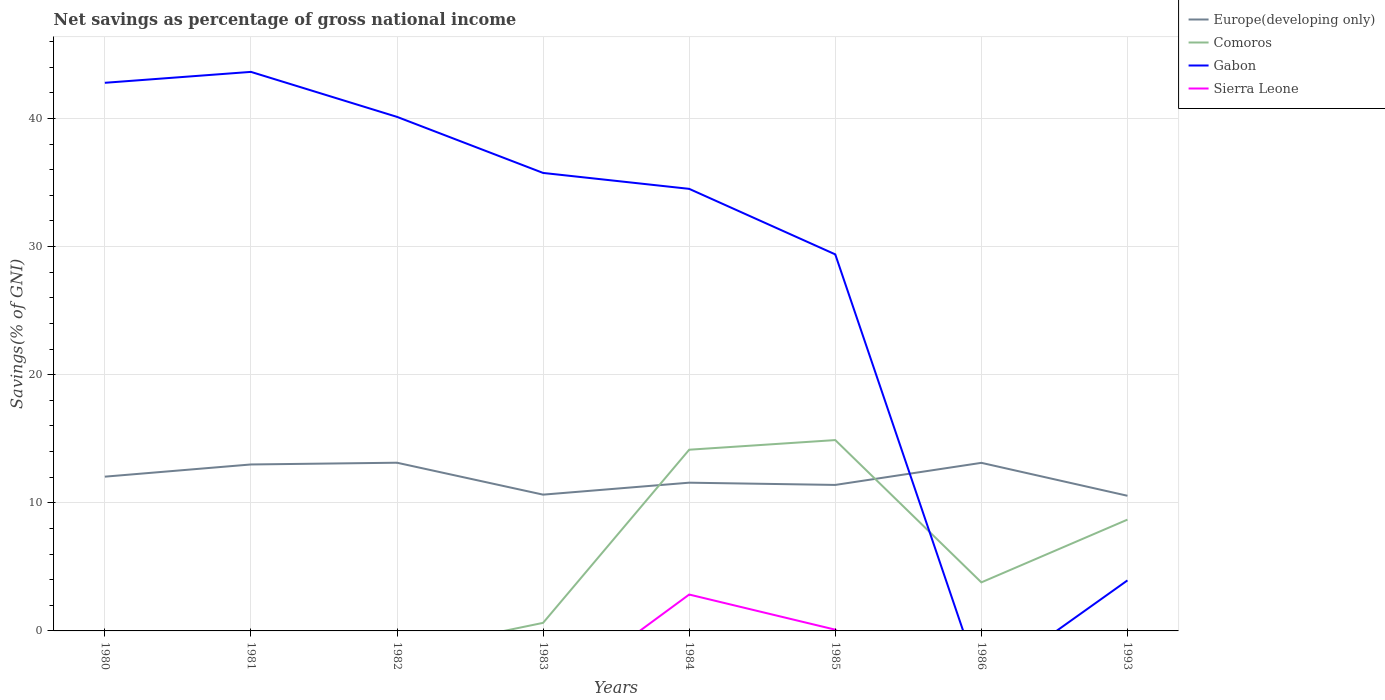Does the line corresponding to Gabon intersect with the line corresponding to Comoros?
Your answer should be very brief. Yes. Across all years, what is the maximum total savings in Sierra Leone?
Keep it short and to the point. 0. What is the total total savings in Europe(developing only) in the graph?
Provide a short and direct response. 2.58. What is the difference between the highest and the second highest total savings in Comoros?
Offer a very short reply. 14.9. What is the difference between the highest and the lowest total savings in Gabon?
Make the answer very short. 6. How many lines are there?
Ensure brevity in your answer.  4. How many years are there in the graph?
Your answer should be very brief. 8. Are the values on the major ticks of Y-axis written in scientific E-notation?
Make the answer very short. No. Does the graph contain any zero values?
Your response must be concise. Yes. What is the title of the graph?
Keep it short and to the point. Net savings as percentage of gross national income. Does "Nicaragua" appear as one of the legend labels in the graph?
Your answer should be very brief. No. What is the label or title of the Y-axis?
Your answer should be very brief. Savings(% of GNI). What is the Savings(% of GNI) of Europe(developing only) in 1980?
Your answer should be compact. 12.04. What is the Savings(% of GNI) in Gabon in 1980?
Keep it short and to the point. 42.78. What is the Savings(% of GNI) of Sierra Leone in 1980?
Your answer should be very brief. 0. What is the Savings(% of GNI) of Europe(developing only) in 1981?
Provide a short and direct response. 12.99. What is the Savings(% of GNI) of Comoros in 1981?
Give a very brief answer. 0. What is the Savings(% of GNI) in Gabon in 1981?
Keep it short and to the point. 43.64. What is the Savings(% of GNI) of Europe(developing only) in 1982?
Offer a terse response. 13.13. What is the Savings(% of GNI) of Comoros in 1982?
Offer a terse response. 0. What is the Savings(% of GNI) of Gabon in 1982?
Provide a succinct answer. 40.12. What is the Savings(% of GNI) of Europe(developing only) in 1983?
Make the answer very short. 10.64. What is the Savings(% of GNI) of Comoros in 1983?
Provide a succinct answer. 0.63. What is the Savings(% of GNI) in Gabon in 1983?
Provide a short and direct response. 35.75. What is the Savings(% of GNI) of Europe(developing only) in 1984?
Provide a succinct answer. 11.57. What is the Savings(% of GNI) in Comoros in 1984?
Keep it short and to the point. 14.14. What is the Savings(% of GNI) in Gabon in 1984?
Your answer should be compact. 34.51. What is the Savings(% of GNI) of Sierra Leone in 1984?
Keep it short and to the point. 2.84. What is the Savings(% of GNI) of Europe(developing only) in 1985?
Keep it short and to the point. 11.4. What is the Savings(% of GNI) of Comoros in 1985?
Offer a terse response. 14.9. What is the Savings(% of GNI) of Gabon in 1985?
Your answer should be very brief. 29.39. What is the Savings(% of GNI) in Sierra Leone in 1985?
Offer a very short reply. 0.1. What is the Savings(% of GNI) in Europe(developing only) in 1986?
Provide a short and direct response. 13.12. What is the Savings(% of GNI) in Comoros in 1986?
Provide a short and direct response. 3.79. What is the Savings(% of GNI) in Europe(developing only) in 1993?
Give a very brief answer. 10.55. What is the Savings(% of GNI) in Comoros in 1993?
Give a very brief answer. 8.69. What is the Savings(% of GNI) of Gabon in 1993?
Ensure brevity in your answer.  3.94. What is the Savings(% of GNI) of Sierra Leone in 1993?
Make the answer very short. 0. Across all years, what is the maximum Savings(% of GNI) of Europe(developing only)?
Offer a terse response. 13.13. Across all years, what is the maximum Savings(% of GNI) of Comoros?
Your response must be concise. 14.9. Across all years, what is the maximum Savings(% of GNI) in Gabon?
Provide a short and direct response. 43.64. Across all years, what is the maximum Savings(% of GNI) in Sierra Leone?
Provide a short and direct response. 2.84. Across all years, what is the minimum Savings(% of GNI) in Europe(developing only)?
Your answer should be very brief. 10.55. Across all years, what is the minimum Savings(% of GNI) of Comoros?
Ensure brevity in your answer.  0. Across all years, what is the minimum Savings(% of GNI) of Sierra Leone?
Your answer should be compact. 0. What is the total Savings(% of GNI) of Europe(developing only) in the graph?
Provide a short and direct response. 95.44. What is the total Savings(% of GNI) in Comoros in the graph?
Offer a very short reply. 42.15. What is the total Savings(% of GNI) in Gabon in the graph?
Offer a terse response. 230.13. What is the total Savings(% of GNI) of Sierra Leone in the graph?
Provide a succinct answer. 2.94. What is the difference between the Savings(% of GNI) of Europe(developing only) in 1980 and that in 1981?
Your answer should be very brief. -0.95. What is the difference between the Savings(% of GNI) of Gabon in 1980 and that in 1981?
Your answer should be compact. -0.85. What is the difference between the Savings(% of GNI) in Europe(developing only) in 1980 and that in 1982?
Offer a very short reply. -1.09. What is the difference between the Savings(% of GNI) in Gabon in 1980 and that in 1982?
Offer a terse response. 2.66. What is the difference between the Savings(% of GNI) in Europe(developing only) in 1980 and that in 1983?
Your answer should be compact. 1.4. What is the difference between the Savings(% of GNI) in Gabon in 1980 and that in 1983?
Offer a terse response. 7.04. What is the difference between the Savings(% of GNI) of Europe(developing only) in 1980 and that in 1984?
Provide a short and direct response. 0.47. What is the difference between the Savings(% of GNI) in Gabon in 1980 and that in 1984?
Ensure brevity in your answer.  8.28. What is the difference between the Savings(% of GNI) of Europe(developing only) in 1980 and that in 1985?
Ensure brevity in your answer.  0.64. What is the difference between the Savings(% of GNI) of Gabon in 1980 and that in 1985?
Give a very brief answer. 13.39. What is the difference between the Savings(% of GNI) of Europe(developing only) in 1980 and that in 1986?
Provide a succinct answer. -1.08. What is the difference between the Savings(% of GNI) in Europe(developing only) in 1980 and that in 1993?
Offer a terse response. 1.49. What is the difference between the Savings(% of GNI) of Gabon in 1980 and that in 1993?
Provide a succinct answer. 38.84. What is the difference between the Savings(% of GNI) in Europe(developing only) in 1981 and that in 1982?
Give a very brief answer. -0.14. What is the difference between the Savings(% of GNI) in Gabon in 1981 and that in 1982?
Offer a terse response. 3.51. What is the difference between the Savings(% of GNI) in Europe(developing only) in 1981 and that in 1983?
Make the answer very short. 2.36. What is the difference between the Savings(% of GNI) in Gabon in 1981 and that in 1983?
Make the answer very short. 7.89. What is the difference between the Savings(% of GNI) of Europe(developing only) in 1981 and that in 1984?
Keep it short and to the point. 1.42. What is the difference between the Savings(% of GNI) in Gabon in 1981 and that in 1984?
Provide a succinct answer. 9.13. What is the difference between the Savings(% of GNI) in Europe(developing only) in 1981 and that in 1985?
Ensure brevity in your answer.  1.6. What is the difference between the Savings(% of GNI) of Gabon in 1981 and that in 1985?
Keep it short and to the point. 14.24. What is the difference between the Savings(% of GNI) of Europe(developing only) in 1981 and that in 1986?
Your answer should be compact. -0.13. What is the difference between the Savings(% of GNI) in Europe(developing only) in 1981 and that in 1993?
Ensure brevity in your answer.  2.44. What is the difference between the Savings(% of GNI) in Gabon in 1981 and that in 1993?
Provide a short and direct response. 39.69. What is the difference between the Savings(% of GNI) of Europe(developing only) in 1982 and that in 1983?
Give a very brief answer. 2.49. What is the difference between the Savings(% of GNI) in Gabon in 1982 and that in 1983?
Keep it short and to the point. 4.38. What is the difference between the Savings(% of GNI) of Europe(developing only) in 1982 and that in 1984?
Provide a short and direct response. 1.56. What is the difference between the Savings(% of GNI) in Gabon in 1982 and that in 1984?
Your response must be concise. 5.62. What is the difference between the Savings(% of GNI) in Europe(developing only) in 1982 and that in 1985?
Provide a short and direct response. 1.73. What is the difference between the Savings(% of GNI) of Gabon in 1982 and that in 1985?
Make the answer very short. 10.73. What is the difference between the Savings(% of GNI) of Europe(developing only) in 1982 and that in 1986?
Provide a short and direct response. 0.01. What is the difference between the Savings(% of GNI) of Europe(developing only) in 1982 and that in 1993?
Keep it short and to the point. 2.58. What is the difference between the Savings(% of GNI) in Gabon in 1982 and that in 1993?
Your response must be concise. 36.18. What is the difference between the Savings(% of GNI) of Europe(developing only) in 1983 and that in 1984?
Offer a terse response. -0.93. What is the difference between the Savings(% of GNI) in Comoros in 1983 and that in 1984?
Ensure brevity in your answer.  -13.51. What is the difference between the Savings(% of GNI) of Gabon in 1983 and that in 1984?
Offer a terse response. 1.24. What is the difference between the Savings(% of GNI) in Europe(developing only) in 1983 and that in 1985?
Provide a short and direct response. -0.76. What is the difference between the Savings(% of GNI) in Comoros in 1983 and that in 1985?
Offer a terse response. -14.27. What is the difference between the Savings(% of GNI) of Gabon in 1983 and that in 1985?
Give a very brief answer. 6.36. What is the difference between the Savings(% of GNI) of Europe(developing only) in 1983 and that in 1986?
Ensure brevity in your answer.  -2.48. What is the difference between the Savings(% of GNI) of Comoros in 1983 and that in 1986?
Offer a terse response. -3.16. What is the difference between the Savings(% of GNI) of Europe(developing only) in 1983 and that in 1993?
Provide a short and direct response. 0.09. What is the difference between the Savings(% of GNI) in Comoros in 1983 and that in 1993?
Offer a terse response. -8.06. What is the difference between the Savings(% of GNI) in Gabon in 1983 and that in 1993?
Make the answer very short. 31.8. What is the difference between the Savings(% of GNI) in Europe(developing only) in 1984 and that in 1985?
Your answer should be very brief. 0.17. What is the difference between the Savings(% of GNI) in Comoros in 1984 and that in 1985?
Your answer should be compact. -0.75. What is the difference between the Savings(% of GNI) in Gabon in 1984 and that in 1985?
Your response must be concise. 5.12. What is the difference between the Savings(% of GNI) in Sierra Leone in 1984 and that in 1985?
Provide a succinct answer. 2.74. What is the difference between the Savings(% of GNI) of Europe(developing only) in 1984 and that in 1986?
Offer a terse response. -1.55. What is the difference between the Savings(% of GNI) in Comoros in 1984 and that in 1986?
Your response must be concise. 10.35. What is the difference between the Savings(% of GNI) in Europe(developing only) in 1984 and that in 1993?
Your answer should be very brief. 1.02. What is the difference between the Savings(% of GNI) of Comoros in 1984 and that in 1993?
Keep it short and to the point. 5.46. What is the difference between the Savings(% of GNI) of Gabon in 1984 and that in 1993?
Your answer should be very brief. 30.56. What is the difference between the Savings(% of GNI) in Europe(developing only) in 1985 and that in 1986?
Provide a short and direct response. -1.72. What is the difference between the Savings(% of GNI) of Comoros in 1985 and that in 1986?
Make the answer very short. 11.11. What is the difference between the Savings(% of GNI) in Europe(developing only) in 1985 and that in 1993?
Your answer should be very brief. 0.85. What is the difference between the Savings(% of GNI) of Comoros in 1985 and that in 1993?
Ensure brevity in your answer.  6.21. What is the difference between the Savings(% of GNI) in Gabon in 1985 and that in 1993?
Keep it short and to the point. 25.45. What is the difference between the Savings(% of GNI) in Europe(developing only) in 1986 and that in 1993?
Provide a succinct answer. 2.57. What is the difference between the Savings(% of GNI) of Comoros in 1986 and that in 1993?
Give a very brief answer. -4.9. What is the difference between the Savings(% of GNI) of Europe(developing only) in 1980 and the Savings(% of GNI) of Gabon in 1981?
Provide a short and direct response. -31.6. What is the difference between the Savings(% of GNI) of Europe(developing only) in 1980 and the Savings(% of GNI) of Gabon in 1982?
Your answer should be very brief. -28.08. What is the difference between the Savings(% of GNI) in Europe(developing only) in 1980 and the Savings(% of GNI) in Comoros in 1983?
Give a very brief answer. 11.41. What is the difference between the Savings(% of GNI) in Europe(developing only) in 1980 and the Savings(% of GNI) in Gabon in 1983?
Ensure brevity in your answer.  -23.71. What is the difference between the Savings(% of GNI) in Europe(developing only) in 1980 and the Savings(% of GNI) in Comoros in 1984?
Your response must be concise. -2.1. What is the difference between the Savings(% of GNI) of Europe(developing only) in 1980 and the Savings(% of GNI) of Gabon in 1984?
Provide a short and direct response. -22.47. What is the difference between the Savings(% of GNI) in Europe(developing only) in 1980 and the Savings(% of GNI) in Sierra Leone in 1984?
Your answer should be compact. 9.2. What is the difference between the Savings(% of GNI) in Gabon in 1980 and the Savings(% of GNI) in Sierra Leone in 1984?
Provide a succinct answer. 39.94. What is the difference between the Savings(% of GNI) of Europe(developing only) in 1980 and the Savings(% of GNI) of Comoros in 1985?
Offer a terse response. -2.86. What is the difference between the Savings(% of GNI) of Europe(developing only) in 1980 and the Savings(% of GNI) of Gabon in 1985?
Provide a succinct answer. -17.35. What is the difference between the Savings(% of GNI) of Europe(developing only) in 1980 and the Savings(% of GNI) of Sierra Leone in 1985?
Offer a very short reply. 11.94. What is the difference between the Savings(% of GNI) in Gabon in 1980 and the Savings(% of GNI) in Sierra Leone in 1985?
Ensure brevity in your answer.  42.69. What is the difference between the Savings(% of GNI) of Europe(developing only) in 1980 and the Savings(% of GNI) of Comoros in 1986?
Your response must be concise. 8.25. What is the difference between the Savings(% of GNI) of Europe(developing only) in 1980 and the Savings(% of GNI) of Comoros in 1993?
Provide a succinct answer. 3.35. What is the difference between the Savings(% of GNI) in Europe(developing only) in 1980 and the Savings(% of GNI) in Gabon in 1993?
Ensure brevity in your answer.  8.1. What is the difference between the Savings(% of GNI) in Europe(developing only) in 1981 and the Savings(% of GNI) in Gabon in 1982?
Your answer should be very brief. -27.13. What is the difference between the Savings(% of GNI) of Europe(developing only) in 1981 and the Savings(% of GNI) of Comoros in 1983?
Give a very brief answer. 12.36. What is the difference between the Savings(% of GNI) of Europe(developing only) in 1981 and the Savings(% of GNI) of Gabon in 1983?
Provide a succinct answer. -22.76. What is the difference between the Savings(% of GNI) in Europe(developing only) in 1981 and the Savings(% of GNI) in Comoros in 1984?
Your answer should be very brief. -1.15. What is the difference between the Savings(% of GNI) of Europe(developing only) in 1981 and the Savings(% of GNI) of Gabon in 1984?
Keep it short and to the point. -21.51. What is the difference between the Savings(% of GNI) of Europe(developing only) in 1981 and the Savings(% of GNI) of Sierra Leone in 1984?
Offer a terse response. 10.15. What is the difference between the Savings(% of GNI) in Gabon in 1981 and the Savings(% of GNI) in Sierra Leone in 1984?
Ensure brevity in your answer.  40.8. What is the difference between the Savings(% of GNI) of Europe(developing only) in 1981 and the Savings(% of GNI) of Comoros in 1985?
Offer a very short reply. -1.9. What is the difference between the Savings(% of GNI) of Europe(developing only) in 1981 and the Savings(% of GNI) of Gabon in 1985?
Your response must be concise. -16.4. What is the difference between the Savings(% of GNI) in Europe(developing only) in 1981 and the Savings(% of GNI) in Sierra Leone in 1985?
Keep it short and to the point. 12.9. What is the difference between the Savings(% of GNI) of Gabon in 1981 and the Savings(% of GNI) of Sierra Leone in 1985?
Keep it short and to the point. 43.54. What is the difference between the Savings(% of GNI) in Europe(developing only) in 1981 and the Savings(% of GNI) in Comoros in 1986?
Offer a very short reply. 9.2. What is the difference between the Savings(% of GNI) of Europe(developing only) in 1981 and the Savings(% of GNI) of Comoros in 1993?
Your answer should be very brief. 4.31. What is the difference between the Savings(% of GNI) of Europe(developing only) in 1981 and the Savings(% of GNI) of Gabon in 1993?
Your response must be concise. 9.05. What is the difference between the Savings(% of GNI) of Europe(developing only) in 1982 and the Savings(% of GNI) of Comoros in 1983?
Your answer should be compact. 12.5. What is the difference between the Savings(% of GNI) of Europe(developing only) in 1982 and the Savings(% of GNI) of Gabon in 1983?
Your answer should be very brief. -22.62. What is the difference between the Savings(% of GNI) of Europe(developing only) in 1982 and the Savings(% of GNI) of Comoros in 1984?
Ensure brevity in your answer.  -1.01. What is the difference between the Savings(% of GNI) of Europe(developing only) in 1982 and the Savings(% of GNI) of Gabon in 1984?
Keep it short and to the point. -21.38. What is the difference between the Savings(% of GNI) in Europe(developing only) in 1982 and the Savings(% of GNI) in Sierra Leone in 1984?
Provide a short and direct response. 10.29. What is the difference between the Savings(% of GNI) of Gabon in 1982 and the Savings(% of GNI) of Sierra Leone in 1984?
Make the answer very short. 37.28. What is the difference between the Savings(% of GNI) in Europe(developing only) in 1982 and the Savings(% of GNI) in Comoros in 1985?
Offer a terse response. -1.77. What is the difference between the Savings(% of GNI) of Europe(developing only) in 1982 and the Savings(% of GNI) of Gabon in 1985?
Provide a succinct answer. -16.26. What is the difference between the Savings(% of GNI) in Europe(developing only) in 1982 and the Savings(% of GNI) in Sierra Leone in 1985?
Your answer should be compact. 13.03. What is the difference between the Savings(% of GNI) of Gabon in 1982 and the Savings(% of GNI) of Sierra Leone in 1985?
Your answer should be compact. 40.03. What is the difference between the Savings(% of GNI) in Europe(developing only) in 1982 and the Savings(% of GNI) in Comoros in 1986?
Make the answer very short. 9.34. What is the difference between the Savings(% of GNI) of Europe(developing only) in 1982 and the Savings(% of GNI) of Comoros in 1993?
Make the answer very short. 4.44. What is the difference between the Savings(% of GNI) of Europe(developing only) in 1982 and the Savings(% of GNI) of Gabon in 1993?
Provide a short and direct response. 9.18. What is the difference between the Savings(% of GNI) in Europe(developing only) in 1983 and the Savings(% of GNI) in Comoros in 1984?
Offer a terse response. -3.51. What is the difference between the Savings(% of GNI) in Europe(developing only) in 1983 and the Savings(% of GNI) in Gabon in 1984?
Keep it short and to the point. -23.87. What is the difference between the Savings(% of GNI) of Europe(developing only) in 1983 and the Savings(% of GNI) of Sierra Leone in 1984?
Your answer should be compact. 7.8. What is the difference between the Savings(% of GNI) in Comoros in 1983 and the Savings(% of GNI) in Gabon in 1984?
Give a very brief answer. -33.88. What is the difference between the Savings(% of GNI) of Comoros in 1983 and the Savings(% of GNI) of Sierra Leone in 1984?
Your answer should be compact. -2.21. What is the difference between the Savings(% of GNI) in Gabon in 1983 and the Savings(% of GNI) in Sierra Leone in 1984?
Provide a short and direct response. 32.91. What is the difference between the Savings(% of GNI) in Europe(developing only) in 1983 and the Savings(% of GNI) in Comoros in 1985?
Your answer should be very brief. -4.26. What is the difference between the Savings(% of GNI) of Europe(developing only) in 1983 and the Savings(% of GNI) of Gabon in 1985?
Ensure brevity in your answer.  -18.75. What is the difference between the Savings(% of GNI) in Europe(developing only) in 1983 and the Savings(% of GNI) in Sierra Leone in 1985?
Provide a short and direct response. 10.54. What is the difference between the Savings(% of GNI) of Comoros in 1983 and the Savings(% of GNI) of Gabon in 1985?
Your answer should be compact. -28.76. What is the difference between the Savings(% of GNI) of Comoros in 1983 and the Savings(% of GNI) of Sierra Leone in 1985?
Offer a terse response. 0.53. What is the difference between the Savings(% of GNI) of Gabon in 1983 and the Savings(% of GNI) of Sierra Leone in 1985?
Offer a terse response. 35.65. What is the difference between the Savings(% of GNI) of Europe(developing only) in 1983 and the Savings(% of GNI) of Comoros in 1986?
Provide a succinct answer. 6.85. What is the difference between the Savings(% of GNI) of Europe(developing only) in 1983 and the Savings(% of GNI) of Comoros in 1993?
Provide a succinct answer. 1.95. What is the difference between the Savings(% of GNI) in Europe(developing only) in 1983 and the Savings(% of GNI) in Gabon in 1993?
Your response must be concise. 6.69. What is the difference between the Savings(% of GNI) of Comoros in 1983 and the Savings(% of GNI) of Gabon in 1993?
Offer a terse response. -3.31. What is the difference between the Savings(% of GNI) in Europe(developing only) in 1984 and the Savings(% of GNI) in Comoros in 1985?
Give a very brief answer. -3.33. What is the difference between the Savings(% of GNI) in Europe(developing only) in 1984 and the Savings(% of GNI) in Gabon in 1985?
Make the answer very short. -17.82. What is the difference between the Savings(% of GNI) of Europe(developing only) in 1984 and the Savings(% of GNI) of Sierra Leone in 1985?
Your response must be concise. 11.47. What is the difference between the Savings(% of GNI) of Comoros in 1984 and the Savings(% of GNI) of Gabon in 1985?
Offer a very short reply. -15.25. What is the difference between the Savings(% of GNI) of Comoros in 1984 and the Savings(% of GNI) of Sierra Leone in 1985?
Your answer should be compact. 14.05. What is the difference between the Savings(% of GNI) in Gabon in 1984 and the Savings(% of GNI) in Sierra Leone in 1985?
Offer a terse response. 34.41. What is the difference between the Savings(% of GNI) of Europe(developing only) in 1984 and the Savings(% of GNI) of Comoros in 1986?
Make the answer very short. 7.78. What is the difference between the Savings(% of GNI) in Europe(developing only) in 1984 and the Savings(% of GNI) in Comoros in 1993?
Make the answer very short. 2.88. What is the difference between the Savings(% of GNI) in Europe(developing only) in 1984 and the Savings(% of GNI) in Gabon in 1993?
Your answer should be compact. 7.63. What is the difference between the Savings(% of GNI) of Comoros in 1984 and the Savings(% of GNI) of Gabon in 1993?
Ensure brevity in your answer.  10.2. What is the difference between the Savings(% of GNI) in Europe(developing only) in 1985 and the Savings(% of GNI) in Comoros in 1986?
Give a very brief answer. 7.61. What is the difference between the Savings(% of GNI) in Europe(developing only) in 1985 and the Savings(% of GNI) in Comoros in 1993?
Your answer should be very brief. 2.71. What is the difference between the Savings(% of GNI) in Europe(developing only) in 1985 and the Savings(% of GNI) in Gabon in 1993?
Ensure brevity in your answer.  7.45. What is the difference between the Savings(% of GNI) in Comoros in 1985 and the Savings(% of GNI) in Gabon in 1993?
Make the answer very short. 10.95. What is the difference between the Savings(% of GNI) of Europe(developing only) in 1986 and the Savings(% of GNI) of Comoros in 1993?
Your response must be concise. 4.43. What is the difference between the Savings(% of GNI) of Europe(developing only) in 1986 and the Savings(% of GNI) of Gabon in 1993?
Make the answer very short. 9.17. What is the difference between the Savings(% of GNI) of Comoros in 1986 and the Savings(% of GNI) of Gabon in 1993?
Provide a succinct answer. -0.15. What is the average Savings(% of GNI) of Europe(developing only) per year?
Provide a succinct answer. 11.93. What is the average Savings(% of GNI) in Comoros per year?
Your answer should be very brief. 5.27. What is the average Savings(% of GNI) in Gabon per year?
Your answer should be compact. 28.77. What is the average Savings(% of GNI) in Sierra Leone per year?
Keep it short and to the point. 0.37. In the year 1980, what is the difference between the Savings(% of GNI) in Europe(developing only) and Savings(% of GNI) in Gabon?
Keep it short and to the point. -30.74. In the year 1981, what is the difference between the Savings(% of GNI) in Europe(developing only) and Savings(% of GNI) in Gabon?
Your answer should be very brief. -30.64. In the year 1982, what is the difference between the Savings(% of GNI) of Europe(developing only) and Savings(% of GNI) of Gabon?
Offer a very short reply. -27. In the year 1983, what is the difference between the Savings(% of GNI) of Europe(developing only) and Savings(% of GNI) of Comoros?
Your answer should be very brief. 10.01. In the year 1983, what is the difference between the Savings(% of GNI) in Europe(developing only) and Savings(% of GNI) in Gabon?
Provide a succinct answer. -25.11. In the year 1983, what is the difference between the Savings(% of GNI) in Comoros and Savings(% of GNI) in Gabon?
Ensure brevity in your answer.  -35.12. In the year 1984, what is the difference between the Savings(% of GNI) of Europe(developing only) and Savings(% of GNI) of Comoros?
Provide a succinct answer. -2.57. In the year 1984, what is the difference between the Savings(% of GNI) in Europe(developing only) and Savings(% of GNI) in Gabon?
Provide a succinct answer. -22.94. In the year 1984, what is the difference between the Savings(% of GNI) in Europe(developing only) and Savings(% of GNI) in Sierra Leone?
Your answer should be compact. 8.73. In the year 1984, what is the difference between the Savings(% of GNI) in Comoros and Savings(% of GNI) in Gabon?
Provide a succinct answer. -20.36. In the year 1984, what is the difference between the Savings(% of GNI) of Comoros and Savings(% of GNI) of Sierra Leone?
Your answer should be compact. 11.3. In the year 1984, what is the difference between the Savings(% of GNI) of Gabon and Savings(% of GNI) of Sierra Leone?
Your answer should be compact. 31.67. In the year 1985, what is the difference between the Savings(% of GNI) of Europe(developing only) and Savings(% of GNI) of Comoros?
Ensure brevity in your answer.  -3.5. In the year 1985, what is the difference between the Savings(% of GNI) of Europe(developing only) and Savings(% of GNI) of Gabon?
Make the answer very short. -17.99. In the year 1985, what is the difference between the Savings(% of GNI) in Europe(developing only) and Savings(% of GNI) in Sierra Leone?
Give a very brief answer. 11.3. In the year 1985, what is the difference between the Savings(% of GNI) of Comoros and Savings(% of GNI) of Gabon?
Keep it short and to the point. -14.49. In the year 1985, what is the difference between the Savings(% of GNI) of Comoros and Savings(% of GNI) of Sierra Leone?
Keep it short and to the point. 14.8. In the year 1985, what is the difference between the Savings(% of GNI) of Gabon and Savings(% of GNI) of Sierra Leone?
Offer a very short reply. 29.29. In the year 1986, what is the difference between the Savings(% of GNI) of Europe(developing only) and Savings(% of GNI) of Comoros?
Provide a succinct answer. 9.33. In the year 1993, what is the difference between the Savings(% of GNI) of Europe(developing only) and Savings(% of GNI) of Comoros?
Offer a very short reply. 1.86. In the year 1993, what is the difference between the Savings(% of GNI) in Europe(developing only) and Savings(% of GNI) in Gabon?
Your answer should be very brief. 6.61. In the year 1993, what is the difference between the Savings(% of GNI) in Comoros and Savings(% of GNI) in Gabon?
Provide a succinct answer. 4.74. What is the ratio of the Savings(% of GNI) of Europe(developing only) in 1980 to that in 1981?
Provide a short and direct response. 0.93. What is the ratio of the Savings(% of GNI) of Gabon in 1980 to that in 1981?
Your answer should be compact. 0.98. What is the ratio of the Savings(% of GNI) in Europe(developing only) in 1980 to that in 1982?
Offer a very short reply. 0.92. What is the ratio of the Savings(% of GNI) in Gabon in 1980 to that in 1982?
Your response must be concise. 1.07. What is the ratio of the Savings(% of GNI) in Europe(developing only) in 1980 to that in 1983?
Your answer should be compact. 1.13. What is the ratio of the Savings(% of GNI) of Gabon in 1980 to that in 1983?
Your answer should be compact. 1.2. What is the ratio of the Savings(% of GNI) in Europe(developing only) in 1980 to that in 1984?
Your answer should be very brief. 1.04. What is the ratio of the Savings(% of GNI) in Gabon in 1980 to that in 1984?
Provide a succinct answer. 1.24. What is the ratio of the Savings(% of GNI) in Europe(developing only) in 1980 to that in 1985?
Offer a terse response. 1.06. What is the ratio of the Savings(% of GNI) in Gabon in 1980 to that in 1985?
Your response must be concise. 1.46. What is the ratio of the Savings(% of GNI) in Europe(developing only) in 1980 to that in 1986?
Your answer should be compact. 0.92. What is the ratio of the Savings(% of GNI) of Europe(developing only) in 1980 to that in 1993?
Ensure brevity in your answer.  1.14. What is the ratio of the Savings(% of GNI) in Gabon in 1980 to that in 1993?
Your answer should be very brief. 10.85. What is the ratio of the Savings(% of GNI) of Gabon in 1981 to that in 1982?
Offer a terse response. 1.09. What is the ratio of the Savings(% of GNI) of Europe(developing only) in 1981 to that in 1983?
Provide a short and direct response. 1.22. What is the ratio of the Savings(% of GNI) of Gabon in 1981 to that in 1983?
Your response must be concise. 1.22. What is the ratio of the Savings(% of GNI) of Europe(developing only) in 1981 to that in 1984?
Make the answer very short. 1.12. What is the ratio of the Savings(% of GNI) of Gabon in 1981 to that in 1984?
Provide a succinct answer. 1.26. What is the ratio of the Savings(% of GNI) in Europe(developing only) in 1981 to that in 1985?
Your response must be concise. 1.14. What is the ratio of the Savings(% of GNI) of Gabon in 1981 to that in 1985?
Your response must be concise. 1.48. What is the ratio of the Savings(% of GNI) of Europe(developing only) in 1981 to that in 1986?
Provide a short and direct response. 0.99. What is the ratio of the Savings(% of GNI) of Europe(developing only) in 1981 to that in 1993?
Keep it short and to the point. 1.23. What is the ratio of the Savings(% of GNI) of Gabon in 1981 to that in 1993?
Make the answer very short. 11.06. What is the ratio of the Savings(% of GNI) of Europe(developing only) in 1982 to that in 1983?
Keep it short and to the point. 1.23. What is the ratio of the Savings(% of GNI) in Gabon in 1982 to that in 1983?
Keep it short and to the point. 1.12. What is the ratio of the Savings(% of GNI) of Europe(developing only) in 1982 to that in 1984?
Your answer should be very brief. 1.13. What is the ratio of the Savings(% of GNI) in Gabon in 1982 to that in 1984?
Provide a succinct answer. 1.16. What is the ratio of the Savings(% of GNI) of Europe(developing only) in 1982 to that in 1985?
Give a very brief answer. 1.15. What is the ratio of the Savings(% of GNI) of Gabon in 1982 to that in 1985?
Your response must be concise. 1.37. What is the ratio of the Savings(% of GNI) in Europe(developing only) in 1982 to that in 1986?
Your answer should be very brief. 1. What is the ratio of the Savings(% of GNI) in Europe(developing only) in 1982 to that in 1993?
Your answer should be compact. 1.24. What is the ratio of the Savings(% of GNI) in Gabon in 1982 to that in 1993?
Offer a terse response. 10.17. What is the ratio of the Savings(% of GNI) of Europe(developing only) in 1983 to that in 1984?
Provide a short and direct response. 0.92. What is the ratio of the Savings(% of GNI) of Comoros in 1983 to that in 1984?
Your answer should be very brief. 0.04. What is the ratio of the Savings(% of GNI) in Gabon in 1983 to that in 1984?
Give a very brief answer. 1.04. What is the ratio of the Savings(% of GNI) in Europe(developing only) in 1983 to that in 1985?
Your response must be concise. 0.93. What is the ratio of the Savings(% of GNI) of Comoros in 1983 to that in 1985?
Ensure brevity in your answer.  0.04. What is the ratio of the Savings(% of GNI) of Gabon in 1983 to that in 1985?
Provide a short and direct response. 1.22. What is the ratio of the Savings(% of GNI) in Europe(developing only) in 1983 to that in 1986?
Offer a terse response. 0.81. What is the ratio of the Savings(% of GNI) of Comoros in 1983 to that in 1986?
Offer a terse response. 0.17. What is the ratio of the Savings(% of GNI) in Europe(developing only) in 1983 to that in 1993?
Provide a succinct answer. 1.01. What is the ratio of the Savings(% of GNI) of Comoros in 1983 to that in 1993?
Provide a short and direct response. 0.07. What is the ratio of the Savings(% of GNI) in Gabon in 1983 to that in 1993?
Make the answer very short. 9.06. What is the ratio of the Savings(% of GNI) of Europe(developing only) in 1984 to that in 1985?
Offer a terse response. 1.02. What is the ratio of the Savings(% of GNI) in Comoros in 1984 to that in 1985?
Your response must be concise. 0.95. What is the ratio of the Savings(% of GNI) in Gabon in 1984 to that in 1985?
Offer a terse response. 1.17. What is the ratio of the Savings(% of GNI) of Sierra Leone in 1984 to that in 1985?
Provide a succinct answer. 29.37. What is the ratio of the Savings(% of GNI) in Europe(developing only) in 1984 to that in 1986?
Keep it short and to the point. 0.88. What is the ratio of the Savings(% of GNI) of Comoros in 1984 to that in 1986?
Ensure brevity in your answer.  3.73. What is the ratio of the Savings(% of GNI) of Europe(developing only) in 1984 to that in 1993?
Ensure brevity in your answer.  1.1. What is the ratio of the Savings(% of GNI) in Comoros in 1984 to that in 1993?
Provide a succinct answer. 1.63. What is the ratio of the Savings(% of GNI) of Gabon in 1984 to that in 1993?
Offer a terse response. 8.75. What is the ratio of the Savings(% of GNI) in Europe(developing only) in 1985 to that in 1986?
Give a very brief answer. 0.87. What is the ratio of the Savings(% of GNI) in Comoros in 1985 to that in 1986?
Make the answer very short. 3.93. What is the ratio of the Savings(% of GNI) in Europe(developing only) in 1985 to that in 1993?
Keep it short and to the point. 1.08. What is the ratio of the Savings(% of GNI) in Comoros in 1985 to that in 1993?
Offer a terse response. 1.71. What is the ratio of the Savings(% of GNI) of Gabon in 1985 to that in 1993?
Ensure brevity in your answer.  7.45. What is the ratio of the Savings(% of GNI) in Europe(developing only) in 1986 to that in 1993?
Provide a short and direct response. 1.24. What is the ratio of the Savings(% of GNI) in Comoros in 1986 to that in 1993?
Your response must be concise. 0.44. What is the difference between the highest and the second highest Savings(% of GNI) in Europe(developing only)?
Your answer should be very brief. 0.01. What is the difference between the highest and the second highest Savings(% of GNI) in Comoros?
Provide a succinct answer. 0.75. What is the difference between the highest and the second highest Savings(% of GNI) of Gabon?
Make the answer very short. 0.85. What is the difference between the highest and the lowest Savings(% of GNI) of Europe(developing only)?
Keep it short and to the point. 2.58. What is the difference between the highest and the lowest Savings(% of GNI) in Comoros?
Keep it short and to the point. 14.9. What is the difference between the highest and the lowest Savings(% of GNI) in Gabon?
Give a very brief answer. 43.64. What is the difference between the highest and the lowest Savings(% of GNI) in Sierra Leone?
Your answer should be compact. 2.84. 